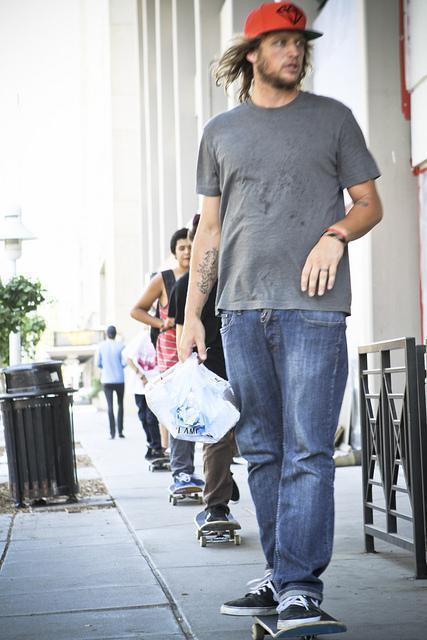How many skateboards are there?
Give a very brief answer. 4. How many people are there?
Give a very brief answer. 5. How many black umbrellas are there?
Give a very brief answer. 0. 